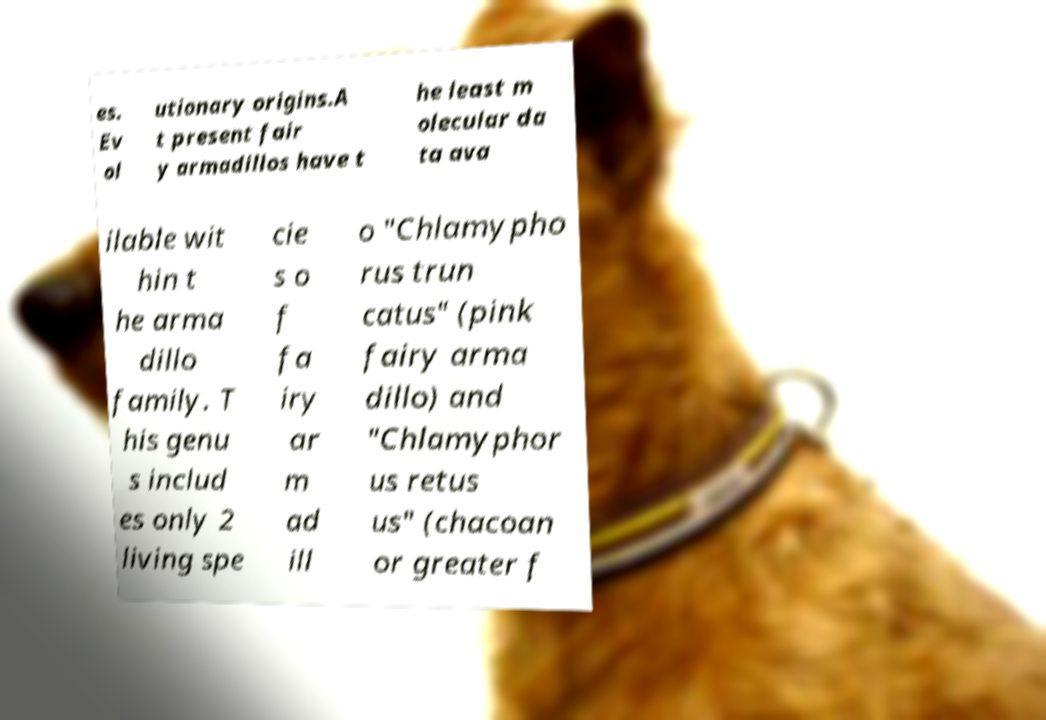I need the written content from this picture converted into text. Can you do that? es. Ev ol utionary origins.A t present fair y armadillos have t he least m olecular da ta ava ilable wit hin t he arma dillo family. T his genu s includ es only 2 living spe cie s o f fa iry ar m ad ill o "Chlamypho rus trun catus" (pink fairy arma dillo) and "Chlamyphor us retus us" (chacoan or greater f 